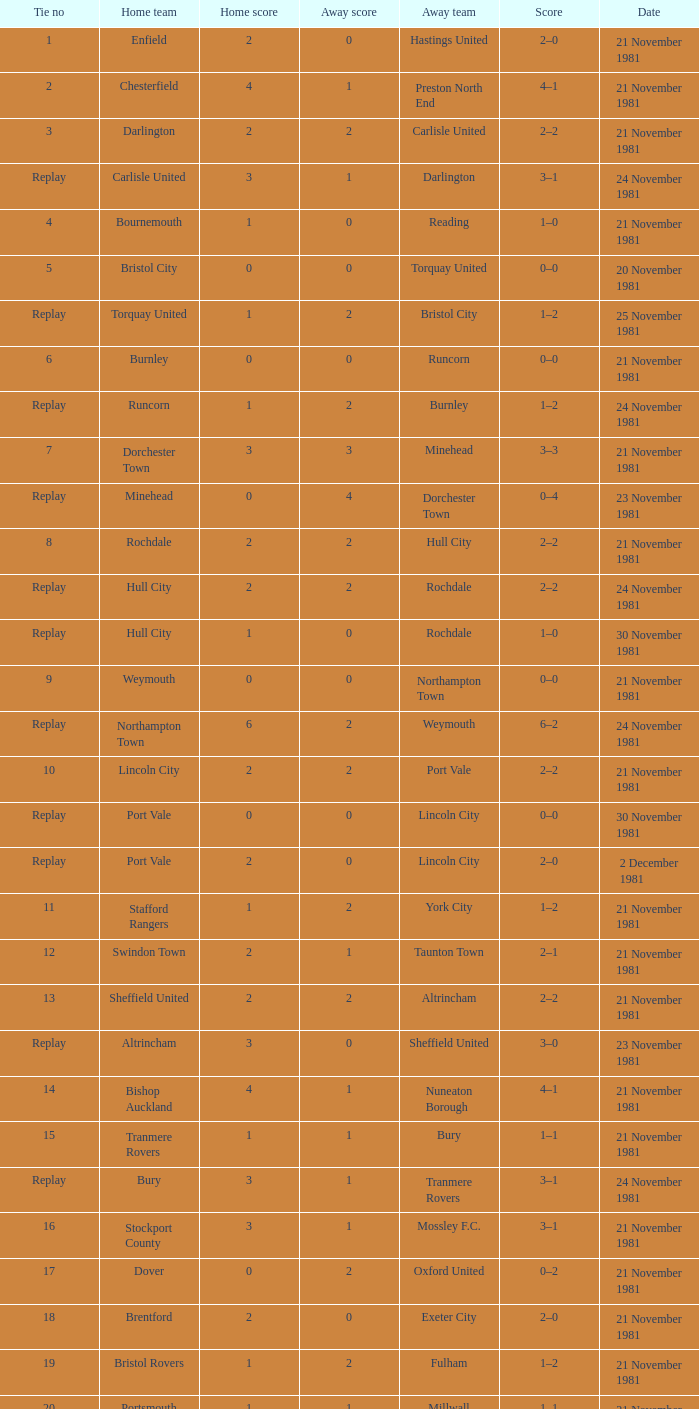What is enfield's tie number? 1.0. 